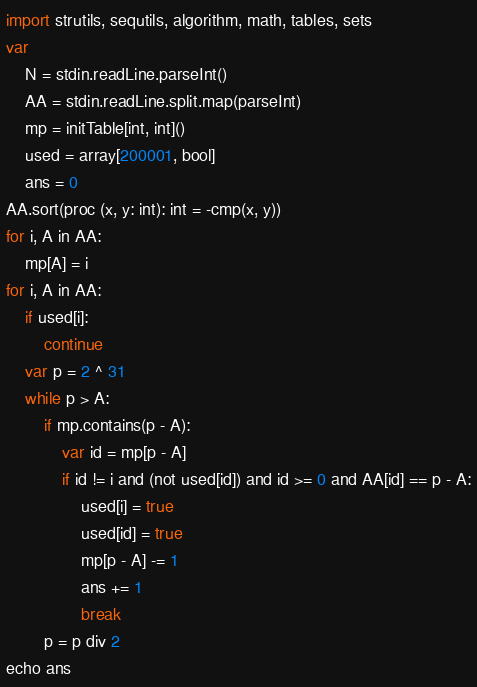Convert code to text. <code><loc_0><loc_0><loc_500><loc_500><_Nim_>
import strutils, sequtils, algorithm, math, tables, sets
var
    N = stdin.readLine.parseInt()
    AA = stdin.readLine.split.map(parseInt)
    mp = initTable[int, int]()
    used = array[200001, bool]
    ans = 0
AA.sort(proc (x, y: int): int = -cmp(x, y))
for i, A in AA:
    mp[A] = i
for i, A in AA:
    if used[i]:
        continue
    var p = 2 ^ 31
    while p > A:
        if mp.contains(p - A):
            var id = mp[p - A]
            if id != i and (not used[id]) and id >= 0 and AA[id] == p - A:
                used[i] = true
                used[id] = true
                mp[p - A] -= 1
                ans += 1
                break
        p = p div 2
echo ans</code> 